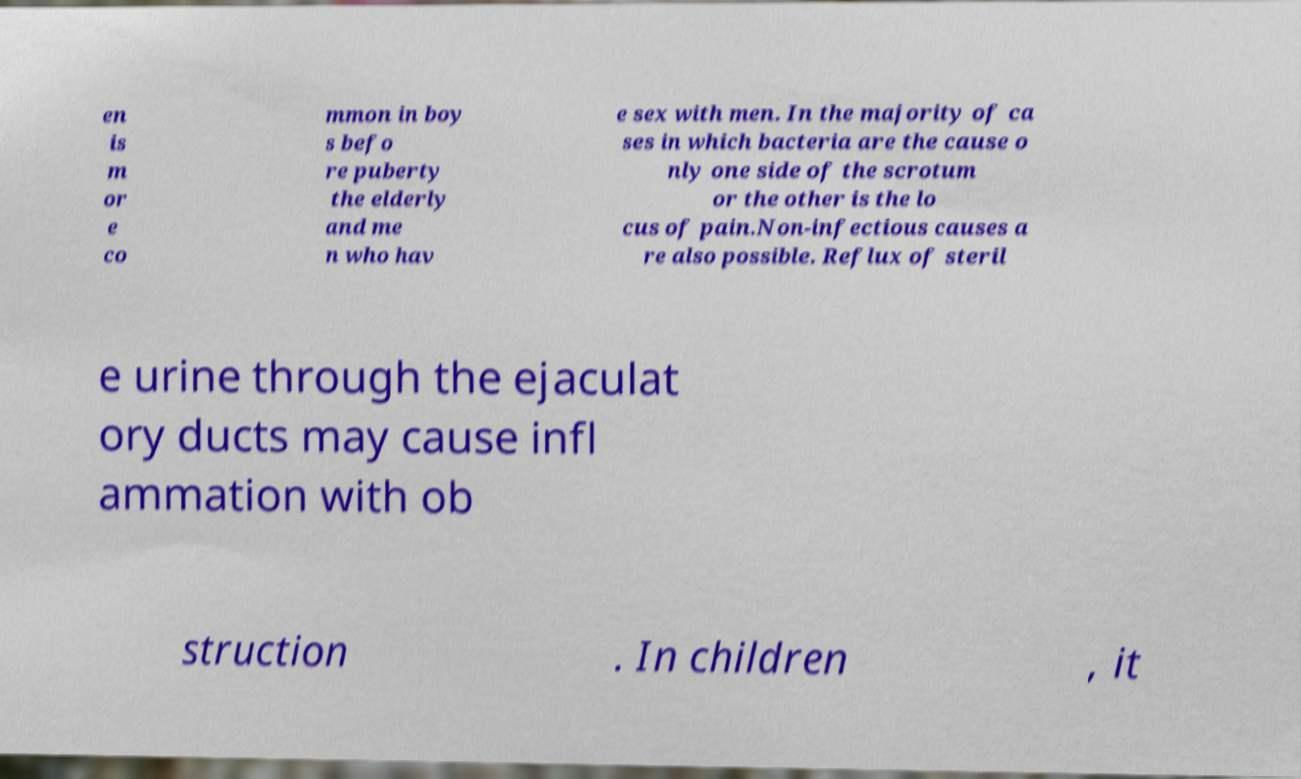There's text embedded in this image that I need extracted. Can you transcribe it verbatim? en is m or e co mmon in boy s befo re puberty the elderly and me n who hav e sex with men. In the majority of ca ses in which bacteria are the cause o nly one side of the scrotum or the other is the lo cus of pain.Non-infectious causes a re also possible. Reflux of steril e urine through the ejaculat ory ducts may cause infl ammation with ob struction . In children , it 